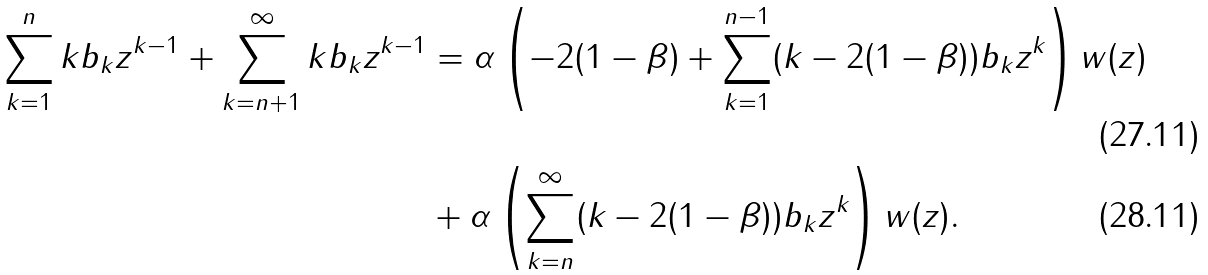<formula> <loc_0><loc_0><loc_500><loc_500>\sum _ { k = 1 } ^ { n } k b _ { k } z ^ { k - 1 } + \sum _ { k = n + 1 } ^ { \infty } k b _ { k } z ^ { k - 1 } & = \alpha \left ( - 2 ( 1 - \beta ) + \sum _ { k = 1 } ^ { n - 1 } ( k - 2 ( 1 - \beta ) ) b _ { k } z ^ { k } \right ) w ( z ) \\ & + \alpha \left ( \sum _ { k = n } ^ { \infty } ( k - 2 ( 1 - \beta ) ) b _ { k } z ^ { k } \right ) w ( z ) .</formula> 